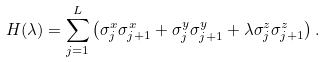Convert formula to latex. <formula><loc_0><loc_0><loc_500><loc_500>H ( \lambda ) = \sum _ { j = 1 } ^ { L } \left ( \sigma _ { j } ^ { x } \sigma _ { j + 1 } ^ { x } + \sigma _ { j } ^ { y } \sigma _ { j + 1 } ^ { y } + \lambda \sigma _ { j } ^ { z } \sigma _ { j + 1 } ^ { z } \right ) .</formula> 